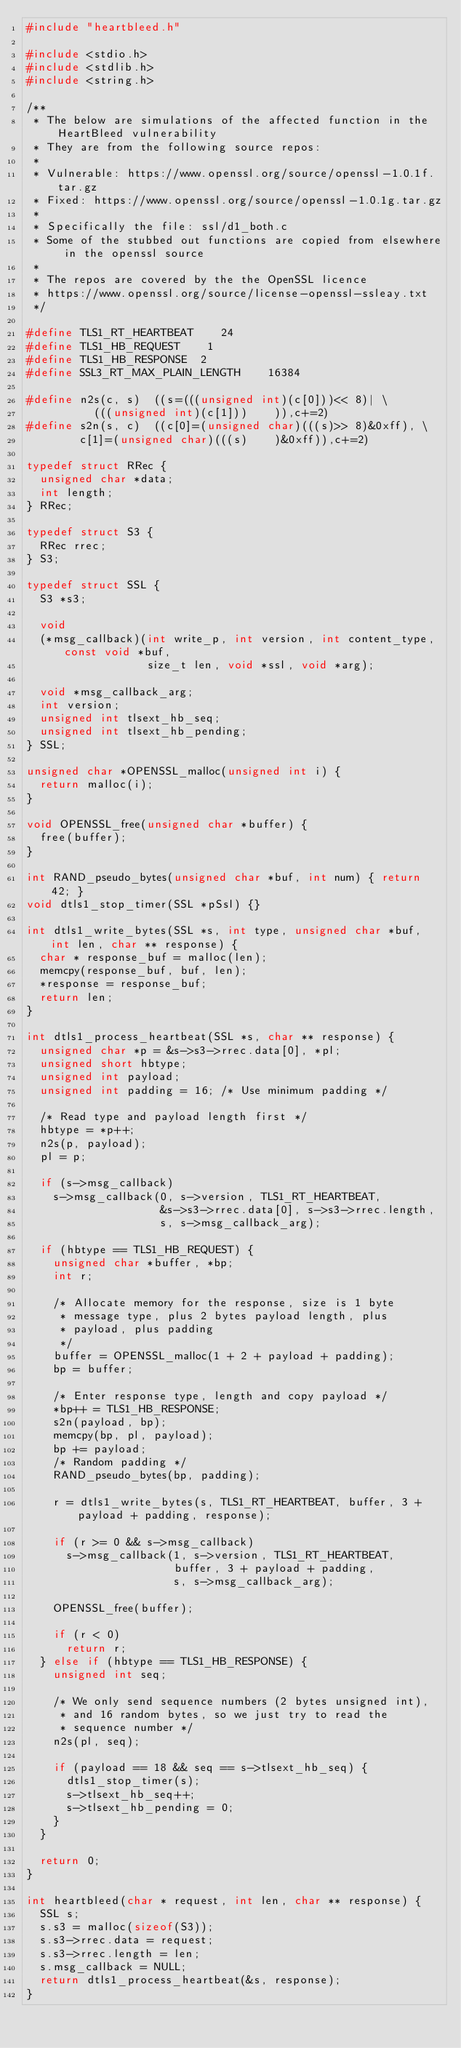Convert code to text. <code><loc_0><loc_0><loc_500><loc_500><_C_>#include "heartbleed.h"

#include <stdio.h>
#include <stdlib.h>
#include <string.h>

/**
 * The below are simulations of the affected function in the HeartBleed vulnerability
 * They are from the following source repos:
 *
 * Vulnerable: https://www.openssl.org/source/openssl-1.0.1f.tar.gz
 * Fixed: https://www.openssl.org/source/openssl-1.0.1g.tar.gz
 *
 * Specifically the file: ssl/d1_both.c
 * Some of the stubbed out functions are copied from elsewhere in the openssl source
 *
 * The repos are covered by the the OpenSSL licence
 * https://www.openssl.org/source/license-openssl-ssleay.txt
 */

#define TLS1_RT_HEARTBEAT    24
#define TLS1_HB_REQUEST    1
#define TLS1_HB_RESPONSE  2
#define SSL3_RT_MAX_PLAIN_LENGTH    16384

#define n2s(c, s)  ((s=(((unsigned int)(c[0]))<< 8)| \
          (((unsigned int)(c[1]))    )),c+=2)
#define s2n(s, c)  ((c[0]=(unsigned char)(((s)>> 8)&0xff), \
        c[1]=(unsigned char)(((s)    )&0xff)),c+=2)

typedef struct RRec {
  unsigned char *data;
  int length;
} RRec;

typedef struct S3 {
  RRec rrec;
} S3;

typedef struct SSL {
  S3 *s3;

  void
  (*msg_callback)(int write_p, int version, int content_type, const void *buf,
                  size_t len, void *ssl, void *arg);

  void *msg_callback_arg;
  int version;
  unsigned int tlsext_hb_seq;
  unsigned int tlsext_hb_pending;
} SSL;

unsigned char *OPENSSL_malloc(unsigned int i) {
  return malloc(i);
}

void OPENSSL_free(unsigned char *buffer) {
  free(buffer);
}

int RAND_pseudo_bytes(unsigned char *buf, int num) { return 42; }
void dtls1_stop_timer(SSL *pSsl) {}

int dtls1_write_bytes(SSL *s, int type, unsigned char *buf, int len, char ** response) {
  char * response_buf = malloc(len);
  memcpy(response_buf, buf, len);
  *response = response_buf;
  return len;
}

int dtls1_process_heartbeat(SSL *s, char ** response) {
  unsigned char *p = &s->s3->rrec.data[0], *pl;
  unsigned short hbtype;
  unsigned int payload;
  unsigned int padding = 16; /* Use minimum padding */

  /* Read type and payload length first */
  hbtype = *p++;
  n2s(p, payload);
  pl = p;

  if (s->msg_callback)
    s->msg_callback(0, s->version, TLS1_RT_HEARTBEAT,
                    &s->s3->rrec.data[0], s->s3->rrec.length,
                    s, s->msg_callback_arg);

  if (hbtype == TLS1_HB_REQUEST) {
    unsigned char *buffer, *bp;
    int r;

    /* Allocate memory for the response, size is 1 byte
     * message type, plus 2 bytes payload length, plus
     * payload, plus padding
     */
    buffer = OPENSSL_malloc(1 + 2 + payload + padding);
    bp = buffer;

    /* Enter response type, length and copy payload */
    *bp++ = TLS1_HB_RESPONSE;
    s2n(payload, bp);
    memcpy(bp, pl, payload);
    bp += payload;
    /* Random padding */
    RAND_pseudo_bytes(bp, padding);

    r = dtls1_write_bytes(s, TLS1_RT_HEARTBEAT, buffer, 3 + payload + padding, response);

    if (r >= 0 && s->msg_callback)
      s->msg_callback(1, s->version, TLS1_RT_HEARTBEAT,
                      buffer, 3 + payload + padding,
                      s, s->msg_callback_arg);

    OPENSSL_free(buffer);

    if (r < 0)
      return r;
  } else if (hbtype == TLS1_HB_RESPONSE) {
    unsigned int seq;

    /* We only send sequence numbers (2 bytes unsigned int),
     * and 16 random bytes, so we just try to read the
     * sequence number */
    n2s(pl, seq);

    if (payload == 18 && seq == s->tlsext_hb_seq) {
      dtls1_stop_timer(s);
      s->tlsext_hb_seq++;
      s->tlsext_hb_pending = 0;
    }
  }

  return 0;
}

int heartbleed(char * request, int len, char ** response) {
  SSL s;
  s.s3 = malloc(sizeof(S3));
  s.s3->rrec.data = request;
  s.s3->rrec.length = len;
  s.msg_callback = NULL;
  return dtls1_process_heartbeat(&s, response);
}
</code> 